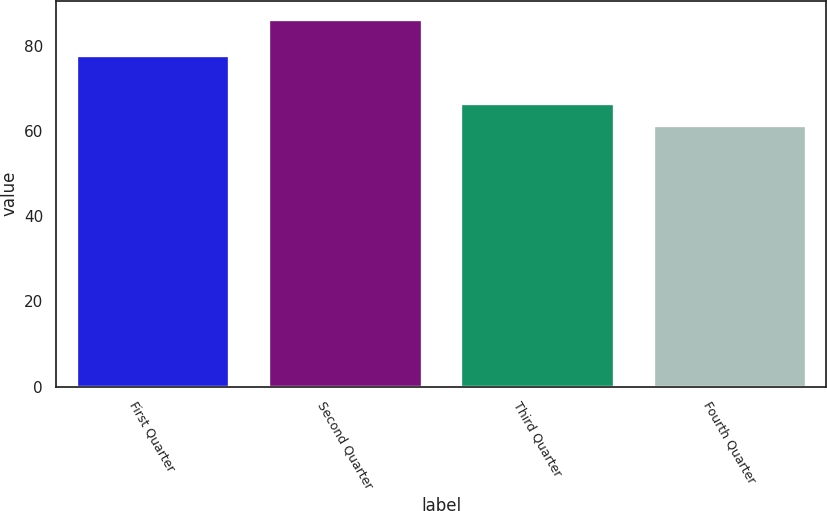Convert chart to OTSL. <chart><loc_0><loc_0><loc_500><loc_500><bar_chart><fcel>First Quarter<fcel>Second Quarter<fcel>Third Quarter<fcel>Fourth Quarter<nl><fcel>78.05<fcel>86.44<fcel>66.77<fcel>61.5<nl></chart> 